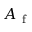Convert formula to latex. <formula><loc_0><loc_0><loc_500><loc_500>A _ { f }</formula> 